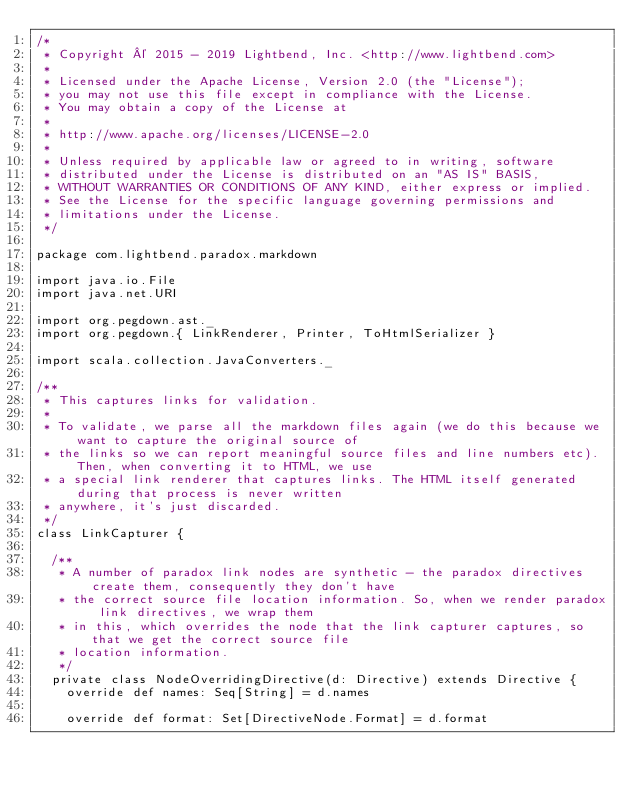<code> <loc_0><loc_0><loc_500><loc_500><_Scala_>/*
 * Copyright © 2015 - 2019 Lightbend, Inc. <http://www.lightbend.com>
 *
 * Licensed under the Apache License, Version 2.0 (the "License");
 * you may not use this file except in compliance with the License.
 * You may obtain a copy of the License at
 *
 * http://www.apache.org/licenses/LICENSE-2.0
 *
 * Unless required by applicable law or agreed to in writing, software
 * distributed under the License is distributed on an "AS IS" BASIS,
 * WITHOUT WARRANTIES OR CONDITIONS OF ANY KIND, either express or implied.
 * See the License for the specific language governing permissions and
 * limitations under the License.
 */

package com.lightbend.paradox.markdown

import java.io.File
import java.net.URI

import org.pegdown.ast._
import org.pegdown.{ LinkRenderer, Printer, ToHtmlSerializer }

import scala.collection.JavaConverters._

/**
 * This captures links for validation.
 *
 * To validate, we parse all the markdown files again (we do this because we want to capture the original source of
 * the links so we can report meaningful source files and line numbers etc). Then, when converting it to HTML, we use
 * a special link renderer that captures links. The HTML itself generated during that process is never written
 * anywhere, it's just discarded.
 */
class LinkCapturer {

  /**
   * A number of paradox link nodes are synthetic - the paradox directives create them, consequently they don't have
   * the correct source file location information. So, when we render paradox link directives, we wrap them
   * in this, which overrides the node that the link capturer captures, so that we get the correct source file
   * location information.
   */
  private class NodeOverridingDirective(d: Directive) extends Directive {
    override def names: Seq[String] = d.names

    override def format: Set[DirectiveNode.Format] = d.format
</code> 